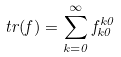Convert formula to latex. <formula><loc_0><loc_0><loc_500><loc_500>t r ( f ) = \sum _ { k = 0 } ^ { \infty } f _ { k 0 } ^ { k 0 }</formula> 